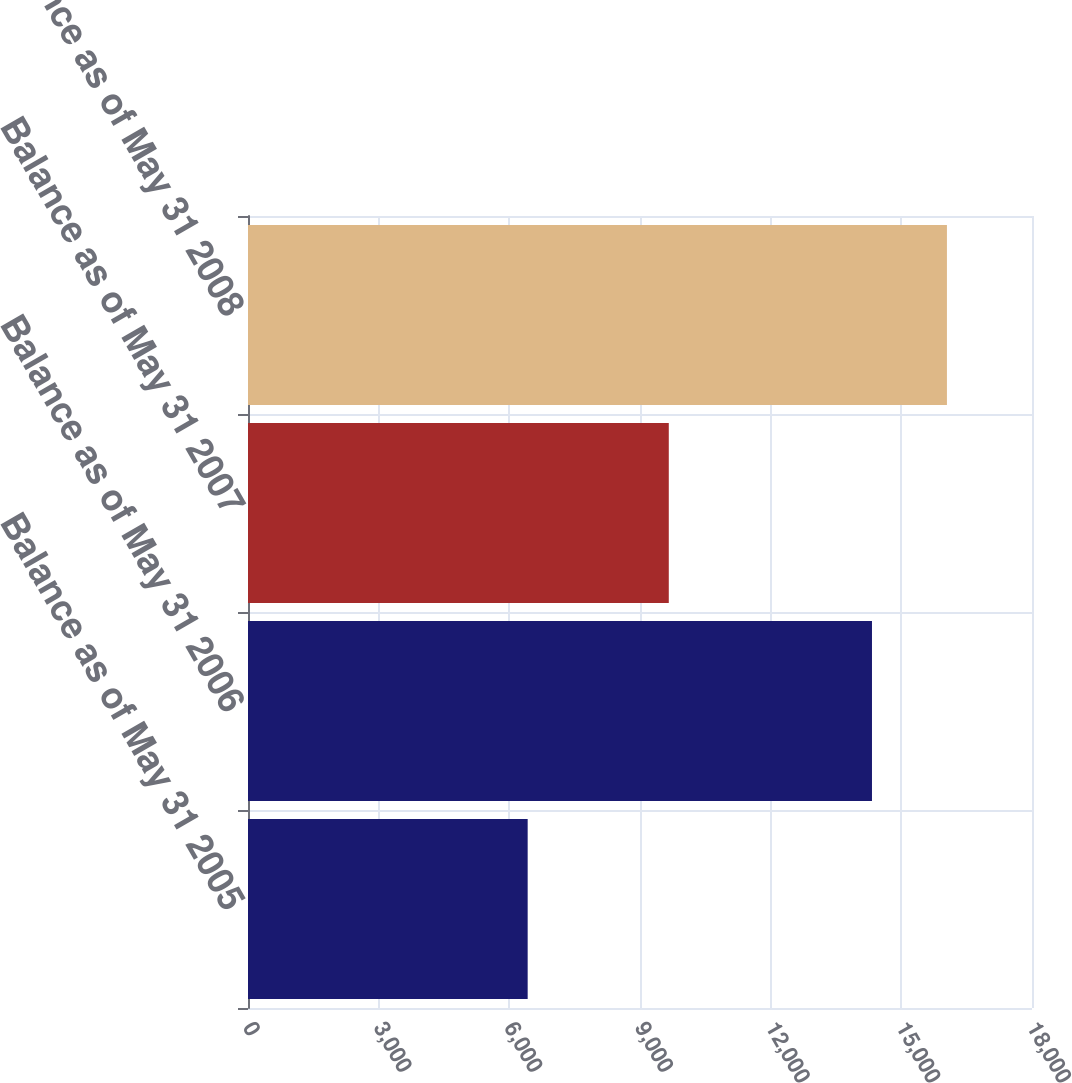Convert chart to OTSL. <chart><loc_0><loc_0><loc_500><loc_500><bar_chart><fcel>Balance as of May 31 2005<fcel>Balance as of May 31 2006<fcel>Balance as of May 31 2007<fcel>Balance as of May 31 2008<nl><fcel>6421<fcel>14326<fcel>9661<fcel>16047<nl></chart> 